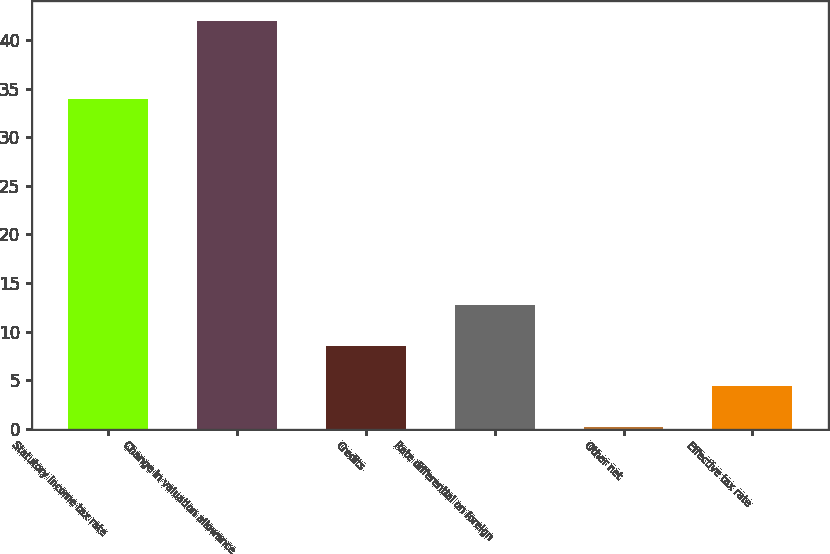<chart> <loc_0><loc_0><loc_500><loc_500><bar_chart><fcel>Statutory income tax rate<fcel>Change in valuation allowance<fcel>Credits<fcel>Rate differential on foreign<fcel>Other net<fcel>Effective tax rate<nl><fcel>34<fcel>42<fcel>8.56<fcel>12.74<fcel>0.2<fcel>4.38<nl></chart> 